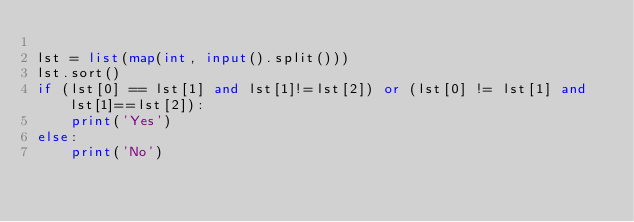<code> <loc_0><loc_0><loc_500><loc_500><_Python_>
lst = list(map(int, input().split()))
lst.sort()
if (lst[0] == lst[1] and lst[1]!=lst[2]) or (lst[0] != lst[1] and lst[1]==lst[2]):
    print('Yes')
else:
    print('No')</code> 